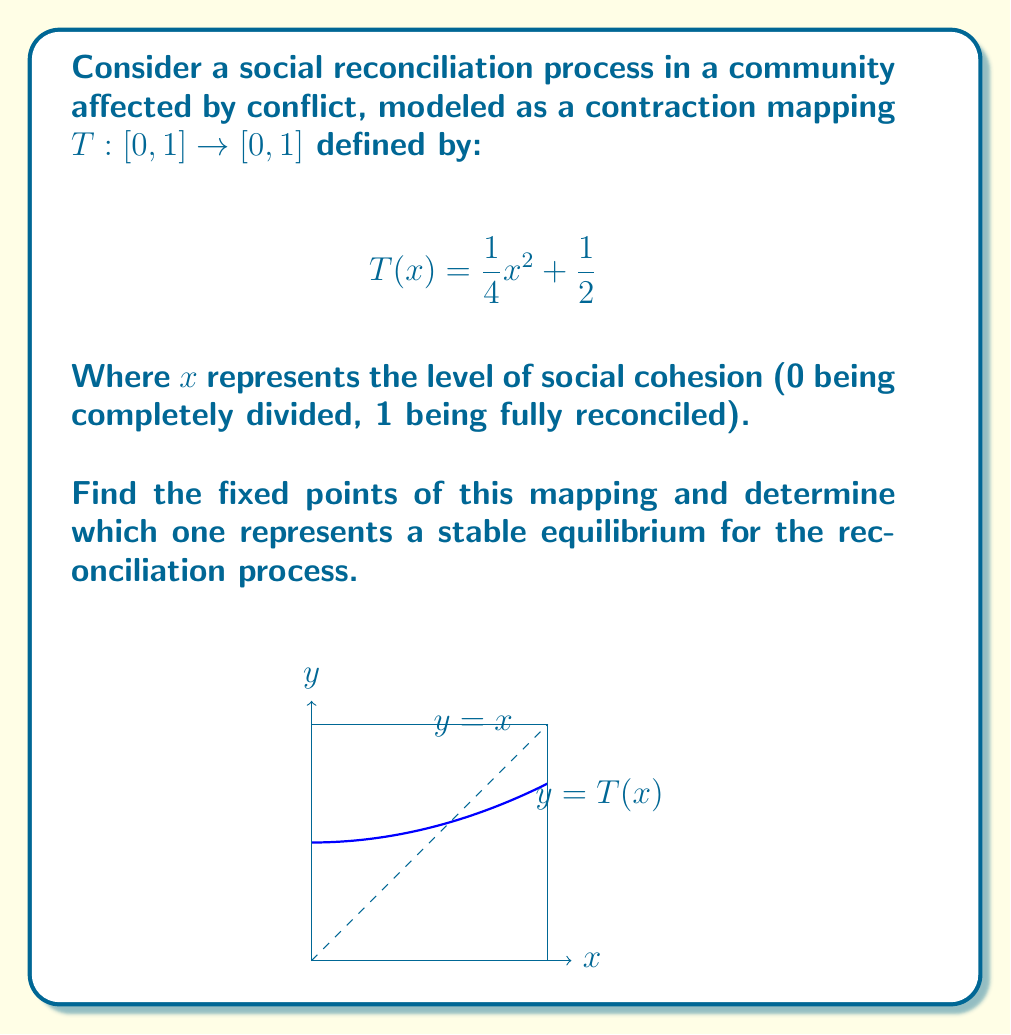Show me your answer to this math problem. Let's approach this step-by-step:

1) Fixed points are values of $x$ where $T(x) = x$. So, we need to solve the equation:

   $$x = \frac{1}{4}x^2 + \frac{1}{2}$$

2) Rearranging the equation:

   $$\frac{1}{4}x^2 - x + \frac{1}{2} = 0$$

3) This is a quadratic equation. We can solve it using the quadratic formula:
   $x = \frac{-b \pm \sqrt{b^2 - 4ac}}{2a}$, where $a=\frac{1}{4}$, $b=-1$, and $c=\frac{1}{2}$

4) Substituting these values:

   $$x = \frac{1 \pm \sqrt{1 - 4(\frac{1}{4})(\frac{1}{2})}}{2(\frac{1}{4})} = 2 \pm \sqrt{2}$$

5) Therefore, the fixed points are:

   $$x_1 = 2 + \sqrt{2} \approx 3.414$$
   $$x_2 = 2 - \sqrt{2} \approx 0.586$$

6) However, since our domain is [0,1], only $x_2$ is a valid fixed point.

7) To determine stability, we check the derivative of $T(x)$ at the fixed point:

   $$T'(x) = \frac{1}{2}x$$

   At $x_2 = 2 - \sqrt{2}$:
   
   $$T'(2 - \sqrt{2}) = \frac{1}{2}(2 - \sqrt{2}) \approx 0.293$$

8) Since $|T'(2 - \sqrt{2})| < 1$, this fixed point is stable.

Therefore, $x_2 = 2 - \sqrt{2}$ is the only valid fixed point and represents a stable equilibrium for the reconciliation process.
Answer: $2 - \sqrt{2}$ 